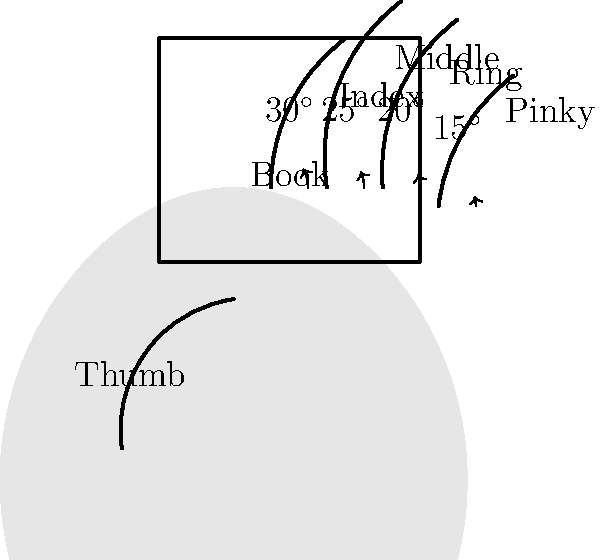As an avid reader of romantic fiction, you often find yourself reading in bed. Based on the hand skeletal diagram shown, what is the ideal angle range for the fingers (excluding the thumb) to comfortably hold a book while minimizing hand fatigue during extended reading sessions? To determine the ideal angle range for comfortable book-holding while reading in bed, we need to consider the biomechanics of the hand and fingers:

1. The diagram shows the hand in a relaxed position, holding a book.
2. The fingers are slightly curved, forming a natural grip on the book.
3. The angles for each finger (excluding the thumb) are indicated:
   - Index finger: 30°
   - Middle finger: 25°
   - Ring finger: 20°
   - Pinky finger: 15°
4. These angles represent a gradual decrease from the index finger to the pinky.
5. The range of angles spans from 15° to 30°.
6. This gradual decrease in angle allows for:
   - Even distribution of pressure across all fingers
   - Reduced strain on any single finger
   - Natural curvature that mimics the relaxed hand position
7. Maintaining this range of angles helps minimize hand fatigue during extended reading sessions.
8. The thumb is positioned separately to support the book from the side or underneath.

Therefore, the ideal angle range for the fingers to comfortably hold a book while minimizing hand fatigue is 15° to 30°.
Answer: 15° to 30° 